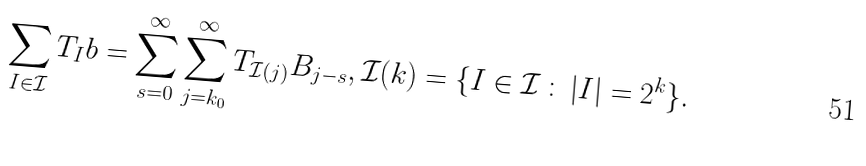<formula> <loc_0><loc_0><loc_500><loc_500>\sum _ { I \in \mathcal { I } } T _ { I } b = \sum _ { s = 0 } ^ { \infty } \sum _ { j = k _ { 0 } } ^ { \infty } T _ { \mathcal { I } ( j ) } B _ { j - s } , \mathcal { I } ( k ) = \{ I \in \mathcal { I } \, \colon \, | I | = 2 ^ { k } \} .</formula> 